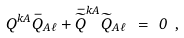Convert formula to latex. <formula><loc_0><loc_0><loc_500><loc_500>Q ^ { k A } \bar { Q } _ { A \ell } + \bar { \widetilde { Q } } ^ { k A } \widetilde { Q } _ { A \ell } \ = \ 0 \ ,</formula> 